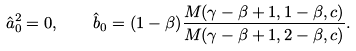<formula> <loc_0><loc_0><loc_500><loc_500>\hat { a } _ { 0 } ^ { 2 } = 0 , \quad { \hat { b } } _ { 0 } = ( 1 - \beta ) \frac { M ( \gamma - \beta + 1 , 1 - \beta , c ) } { M ( \gamma - \beta + 1 , 2 - \beta , c ) } .</formula> 